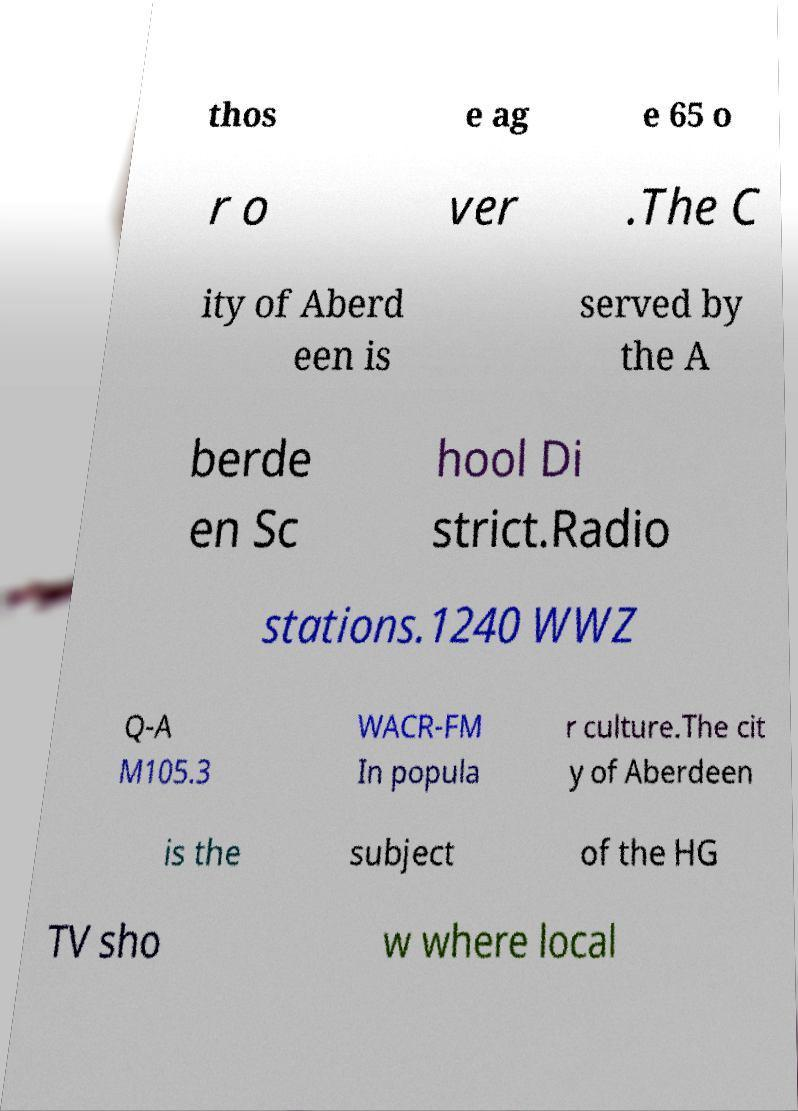There's text embedded in this image that I need extracted. Can you transcribe it verbatim? thos e ag e 65 o r o ver .The C ity of Aberd een is served by the A berde en Sc hool Di strict.Radio stations.1240 WWZ Q-A M105.3 WACR-FM In popula r culture.The cit y of Aberdeen is the subject of the HG TV sho w where local 